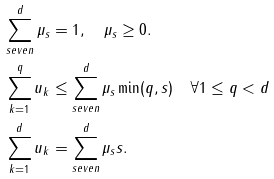<formula> <loc_0><loc_0><loc_500><loc_500>\sum _ { s e v e n } ^ { d } \mu _ { s } & = 1 , \quad \mu _ { s } \geq 0 . \\ \sum _ { k = 1 } ^ { q } u _ { k } & \leq \sum _ { s e v e n } ^ { d } \mu _ { s } \min ( q , s ) \quad \forall 1 \leq q < d \\ \sum _ { k = 1 } ^ { d } u _ { k } & = \sum _ { s e v e n } ^ { d } \mu _ { s } s . \\</formula> 